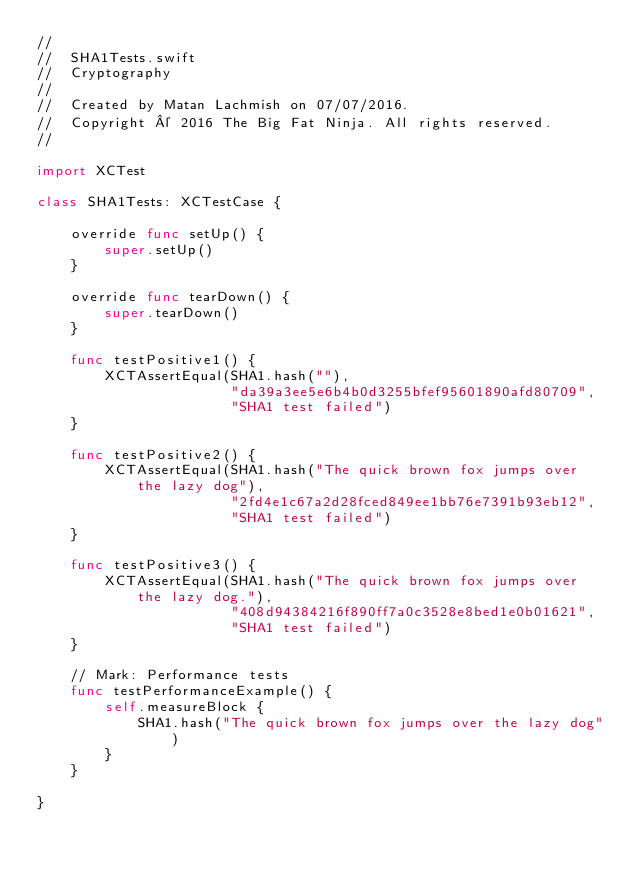Convert code to text. <code><loc_0><loc_0><loc_500><loc_500><_Swift_>//
//  SHA1Tests.swift
//  Cryptography
//
//  Created by Matan Lachmish on 07/07/2016.
//  Copyright © 2016 The Big Fat Ninja. All rights reserved.
//

import XCTest

class SHA1Tests: XCTestCase {

    override func setUp() {
        super.setUp()
    }

    override func tearDown() {
        super.tearDown()
    }

    func testPositive1() {
        XCTAssertEqual(SHA1.hash(""),
                       "da39a3ee5e6b4b0d3255bfef95601890afd80709",
                       "SHA1 test failed")
    }

    func testPositive2() {
        XCTAssertEqual(SHA1.hash("The quick brown fox jumps over the lazy dog"),
                       "2fd4e1c67a2d28fced849ee1bb76e7391b93eb12",
                       "SHA1 test failed")
    }

    func testPositive3() {
        XCTAssertEqual(SHA1.hash("The quick brown fox jumps over the lazy dog."),
                       "408d94384216f890ff7a0c3528e8bed1e0b01621",
                       "SHA1 test failed")
    }

    // Mark: Performance tests
    func testPerformanceExample() {
        self.measureBlock {
            SHA1.hash("The quick brown fox jumps over the lazy dog")
        }
    }

}
</code> 